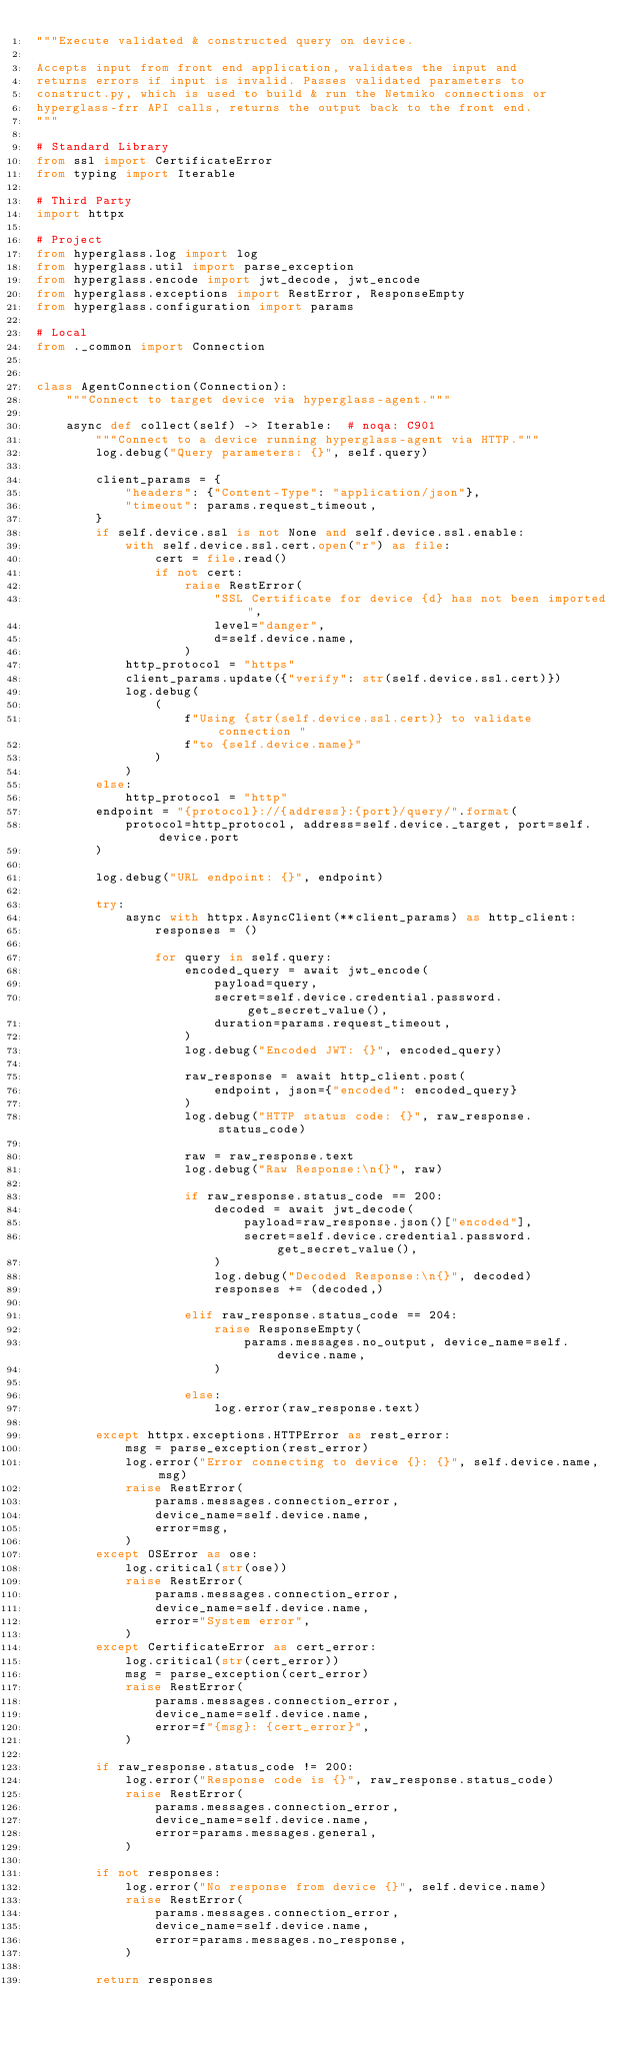<code> <loc_0><loc_0><loc_500><loc_500><_Python_>"""Execute validated & constructed query on device.

Accepts input from front end application, validates the input and
returns errors if input is invalid. Passes validated parameters to
construct.py, which is used to build & run the Netmiko connections or
hyperglass-frr API calls, returns the output back to the front end.
"""

# Standard Library
from ssl import CertificateError
from typing import Iterable

# Third Party
import httpx

# Project
from hyperglass.log import log
from hyperglass.util import parse_exception
from hyperglass.encode import jwt_decode, jwt_encode
from hyperglass.exceptions import RestError, ResponseEmpty
from hyperglass.configuration import params

# Local
from ._common import Connection


class AgentConnection(Connection):
    """Connect to target device via hyperglass-agent."""

    async def collect(self) -> Iterable:  # noqa: C901
        """Connect to a device running hyperglass-agent via HTTP."""
        log.debug("Query parameters: {}", self.query)

        client_params = {
            "headers": {"Content-Type": "application/json"},
            "timeout": params.request_timeout,
        }
        if self.device.ssl is not None and self.device.ssl.enable:
            with self.device.ssl.cert.open("r") as file:
                cert = file.read()
                if not cert:
                    raise RestError(
                        "SSL Certificate for device {d} has not been imported",
                        level="danger",
                        d=self.device.name,
                    )
            http_protocol = "https"
            client_params.update({"verify": str(self.device.ssl.cert)})
            log.debug(
                (
                    f"Using {str(self.device.ssl.cert)} to validate connection "
                    f"to {self.device.name}"
                )
            )
        else:
            http_protocol = "http"
        endpoint = "{protocol}://{address}:{port}/query/".format(
            protocol=http_protocol, address=self.device._target, port=self.device.port
        )

        log.debug("URL endpoint: {}", endpoint)

        try:
            async with httpx.AsyncClient(**client_params) as http_client:
                responses = ()

                for query in self.query:
                    encoded_query = await jwt_encode(
                        payload=query,
                        secret=self.device.credential.password.get_secret_value(),
                        duration=params.request_timeout,
                    )
                    log.debug("Encoded JWT: {}", encoded_query)

                    raw_response = await http_client.post(
                        endpoint, json={"encoded": encoded_query}
                    )
                    log.debug("HTTP status code: {}", raw_response.status_code)

                    raw = raw_response.text
                    log.debug("Raw Response:\n{}", raw)

                    if raw_response.status_code == 200:
                        decoded = await jwt_decode(
                            payload=raw_response.json()["encoded"],
                            secret=self.device.credential.password.get_secret_value(),
                        )
                        log.debug("Decoded Response:\n{}", decoded)
                        responses += (decoded,)

                    elif raw_response.status_code == 204:
                        raise ResponseEmpty(
                            params.messages.no_output, device_name=self.device.name,
                        )

                    else:
                        log.error(raw_response.text)

        except httpx.exceptions.HTTPError as rest_error:
            msg = parse_exception(rest_error)
            log.error("Error connecting to device {}: {}", self.device.name, msg)
            raise RestError(
                params.messages.connection_error,
                device_name=self.device.name,
                error=msg,
            )
        except OSError as ose:
            log.critical(str(ose))
            raise RestError(
                params.messages.connection_error,
                device_name=self.device.name,
                error="System error",
            )
        except CertificateError as cert_error:
            log.critical(str(cert_error))
            msg = parse_exception(cert_error)
            raise RestError(
                params.messages.connection_error,
                device_name=self.device.name,
                error=f"{msg}: {cert_error}",
            )

        if raw_response.status_code != 200:
            log.error("Response code is {}", raw_response.status_code)
            raise RestError(
                params.messages.connection_error,
                device_name=self.device.name,
                error=params.messages.general,
            )

        if not responses:
            log.error("No response from device {}", self.device.name)
            raise RestError(
                params.messages.connection_error,
                device_name=self.device.name,
                error=params.messages.no_response,
            )

        return responses
</code> 